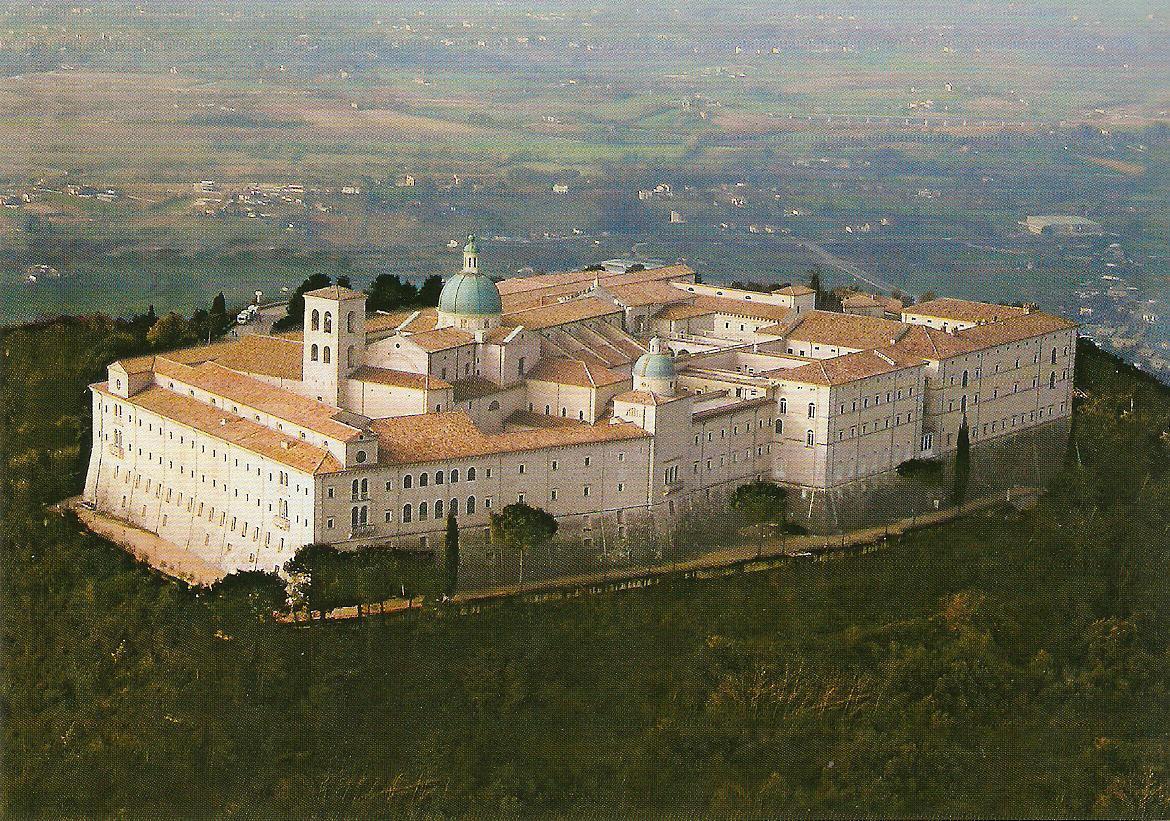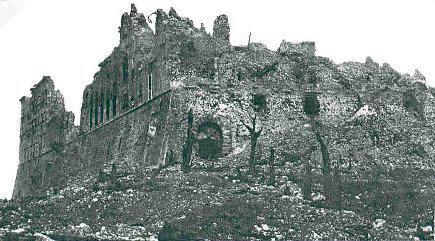The first image is the image on the left, the second image is the image on the right. For the images shown, is this caption "An image shows a stone-floored courtyard surrounded by arches, with a view through the arches into an empty distance." true? Answer yes or no. No. The first image is the image on the left, the second image is the image on the right. For the images shown, is this caption "The building in the image on the left is surrounded by lush greenery." true? Answer yes or no. Yes. 